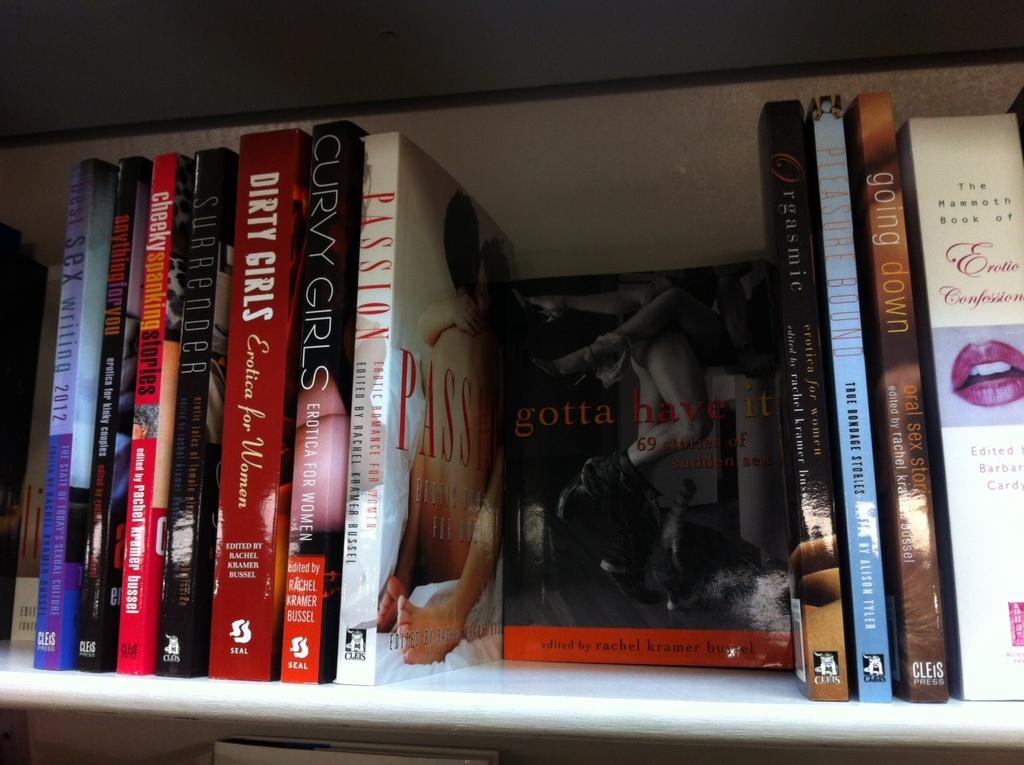What topic is the book going down about?
Your response must be concise. Oral sex. 